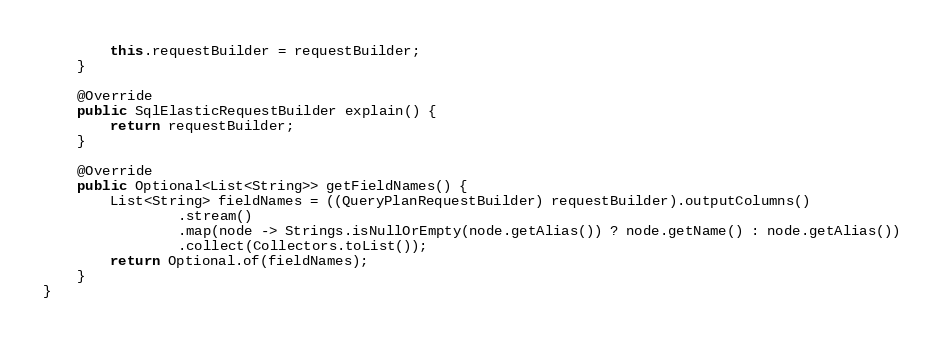<code> <loc_0><loc_0><loc_500><loc_500><_Java_>        this.requestBuilder = requestBuilder;
    }

    @Override
    public SqlElasticRequestBuilder explain() {
        return requestBuilder;
    }

    @Override
    public Optional<List<String>> getFieldNames() {
        List<String> fieldNames = ((QueryPlanRequestBuilder) requestBuilder).outputColumns()
                .stream()
                .map(node -> Strings.isNullOrEmpty(node.getAlias()) ? node.getName() : node.getAlias())
                .collect(Collectors.toList());
        return Optional.of(fieldNames);
    }
}
</code> 